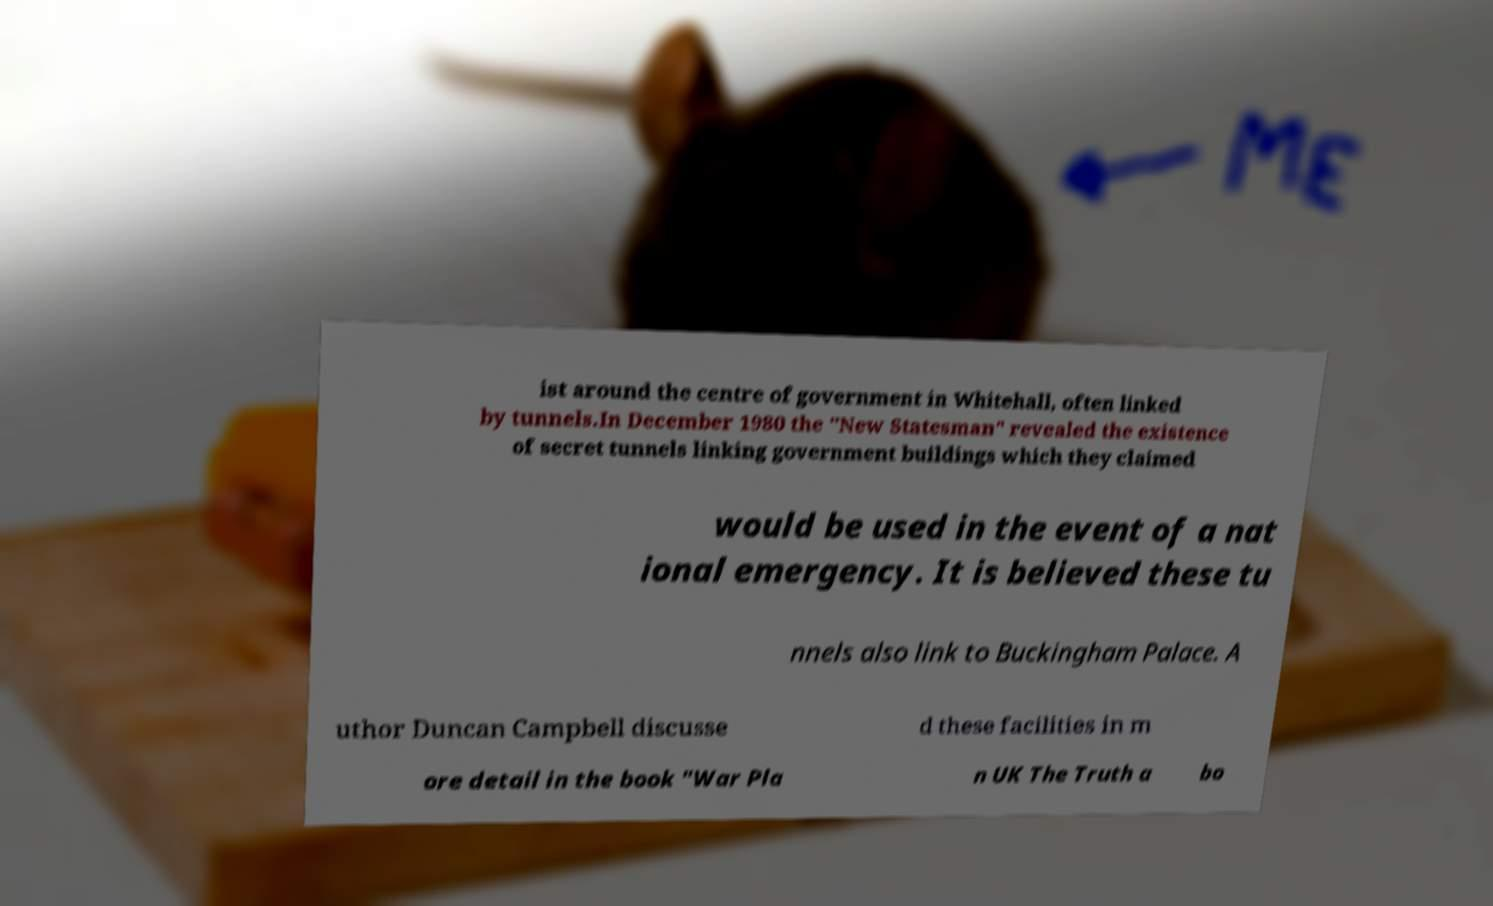What messages or text are displayed in this image? I need them in a readable, typed format. ist around the centre of government in Whitehall, often linked by tunnels.In December 1980 the "New Statesman" revealed the existence of secret tunnels linking government buildings which they claimed would be used in the event of a nat ional emergency. It is believed these tu nnels also link to Buckingham Palace. A uthor Duncan Campbell discusse d these facilities in m ore detail in the book "War Pla n UK The Truth a bo 